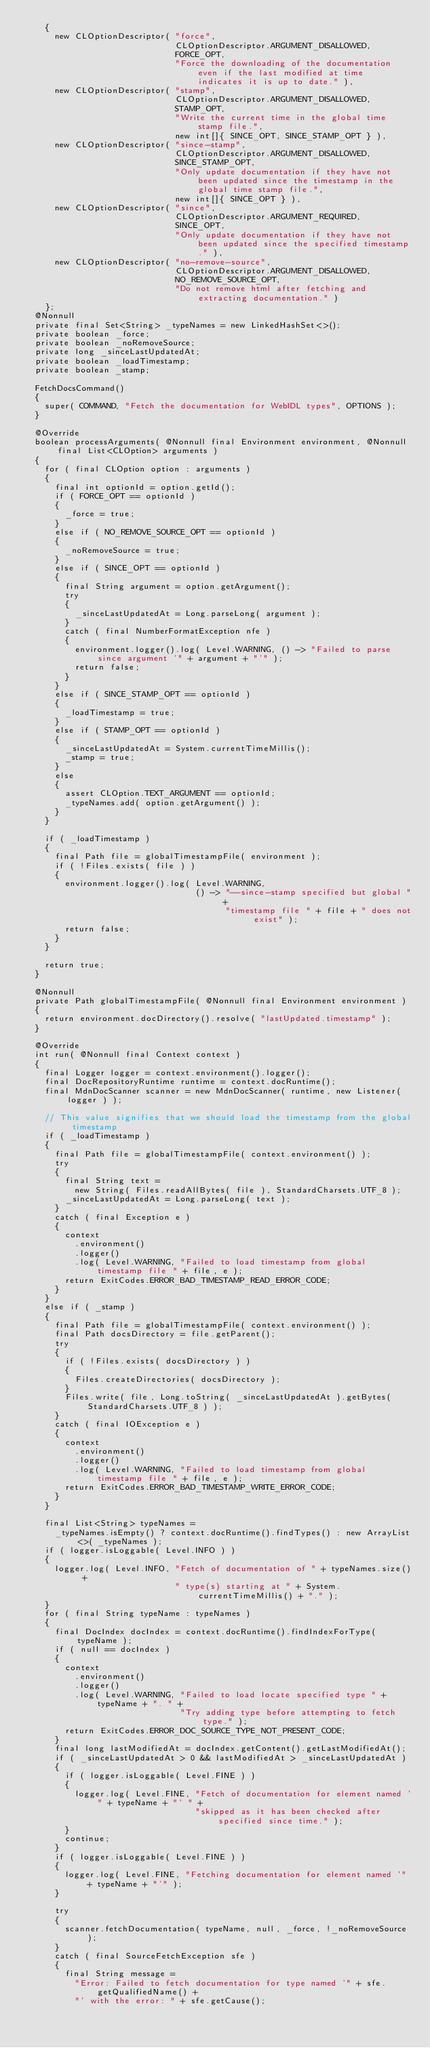<code> <loc_0><loc_0><loc_500><loc_500><_Java_>    {
      new CLOptionDescriptor( "force",
                              CLOptionDescriptor.ARGUMENT_DISALLOWED,
                              FORCE_OPT,
                              "Force the downloading of the documentation even if the last modified at time indicates it is up to date." ),
      new CLOptionDescriptor( "stamp",
                              CLOptionDescriptor.ARGUMENT_DISALLOWED,
                              STAMP_OPT,
                              "Write the current time in the global time stamp file.",
                              new int[]{ SINCE_OPT, SINCE_STAMP_OPT } ),
      new CLOptionDescriptor( "since-stamp",
                              CLOptionDescriptor.ARGUMENT_DISALLOWED,
                              SINCE_STAMP_OPT,
                              "Only update documentation if they have not been updated since the timestamp in the global time stamp file.",
                              new int[]{ SINCE_OPT } ),
      new CLOptionDescriptor( "since",
                              CLOptionDescriptor.ARGUMENT_REQUIRED,
                              SINCE_OPT,
                              "Only update documentation if they have not been updated since the specified timestamp." ),
      new CLOptionDescriptor( "no-remove-source",
                              CLOptionDescriptor.ARGUMENT_DISALLOWED,
                              NO_REMOVE_SOURCE_OPT,
                              "Do not remove html after fetching and extracting documentation." )
    };
  @Nonnull
  private final Set<String> _typeNames = new LinkedHashSet<>();
  private boolean _force;
  private boolean _noRemoveSource;
  private long _sinceLastUpdatedAt;
  private boolean _loadTimestamp;
  private boolean _stamp;

  FetchDocsCommand()
  {
    super( COMMAND, "Fetch the documentation for WebIDL types", OPTIONS );
  }

  @Override
  boolean processArguments( @Nonnull final Environment environment, @Nonnull final List<CLOption> arguments )
  {
    for ( final CLOption option : arguments )
    {
      final int optionId = option.getId();
      if ( FORCE_OPT == optionId )
      {
        _force = true;
      }
      else if ( NO_REMOVE_SOURCE_OPT == optionId )
      {
        _noRemoveSource = true;
      }
      else if ( SINCE_OPT == optionId )
      {
        final String argument = option.getArgument();
        try
        {
          _sinceLastUpdatedAt = Long.parseLong( argument );
        }
        catch ( final NumberFormatException nfe )
        {
          environment.logger().log( Level.WARNING, () -> "Failed to parse since argument '" + argument + "'" );
          return false;
        }
      }
      else if ( SINCE_STAMP_OPT == optionId )
      {
        _loadTimestamp = true;
      }
      else if ( STAMP_OPT == optionId )
      {
        _sinceLastUpdatedAt = System.currentTimeMillis();
        _stamp = true;
      }
      else
      {
        assert CLOption.TEXT_ARGUMENT == optionId;
        _typeNames.add( option.getArgument() );
      }
    }

    if ( _loadTimestamp )
    {
      final Path file = globalTimestampFile( environment );
      if ( !Files.exists( file ) )
      {
        environment.logger().log( Level.WARNING,
                                  () -> "--since-stamp specified but global " +
                                        "timestamp file " + file + " does not exist" );
        return false;
      }
    }

    return true;
  }

  @Nonnull
  private Path globalTimestampFile( @Nonnull final Environment environment )
  {
    return environment.docDirectory().resolve( "lastUpdated.timestamp" );
  }

  @Override
  int run( @Nonnull final Context context )
  {
    final Logger logger = context.environment().logger();
    final DocRepositoryRuntime runtime = context.docRuntime();
    final MdnDocScanner scanner = new MdnDocScanner( runtime, new Listener( logger ) );

    // This value signifies that we should load the timestamp from the global timestamp
    if ( _loadTimestamp )
    {
      final Path file = globalTimestampFile( context.environment() );
      try
      {
        final String text =
          new String( Files.readAllBytes( file ), StandardCharsets.UTF_8 );
        _sinceLastUpdatedAt = Long.parseLong( text );
      }
      catch ( final Exception e )
      {
        context
          .environment()
          .logger()
          .log( Level.WARNING, "Failed to load timestamp from global timestamp file " + file, e );
        return ExitCodes.ERROR_BAD_TIMESTAMP_READ_ERROR_CODE;
      }
    }
    else if ( _stamp )
    {
      final Path file = globalTimestampFile( context.environment() );
      final Path docsDirectory = file.getParent();
      try
      {
        if ( !Files.exists( docsDirectory ) )
        {
          Files.createDirectories( docsDirectory );
        }
        Files.write( file, Long.toString( _sinceLastUpdatedAt ).getBytes( StandardCharsets.UTF_8 ) );
      }
      catch ( final IOException e )
      {
        context
          .environment()
          .logger()
          .log( Level.WARNING, "Failed to load timestamp from global timestamp file " + file, e );
        return ExitCodes.ERROR_BAD_TIMESTAMP_WRITE_ERROR_CODE;
      }
    }

    final List<String> typeNames =
      _typeNames.isEmpty() ? context.docRuntime().findTypes() : new ArrayList<>( _typeNames );
    if ( logger.isLoggable( Level.INFO ) )
    {
      logger.log( Level.INFO, "Fetch of documentation of " + typeNames.size() +
                              " type(s) starting at " + System.currentTimeMillis() + "." );
    }
    for ( final String typeName : typeNames )
    {
      final DocIndex docIndex = context.docRuntime().findIndexForType( typeName );
      if ( null == docIndex )
      {
        context
          .environment()
          .logger()
          .log( Level.WARNING, "Failed to load locate specified type " + typeName + ". " +
                               "Try adding type before attempting to fetch type." );
        return ExitCodes.ERROR_DOC_SOURCE_TYPE_NOT_PRESENT_CODE;
      }
      final long lastModifiedAt = docIndex.getContent().getLastModifiedAt();
      if ( _sinceLastUpdatedAt > 0 && lastModifiedAt > _sinceLastUpdatedAt )
      {
        if ( logger.isLoggable( Level.FINE ) )
        {
          logger.log( Level.FINE, "Fetch of documentation for element named '" + typeName + "' " +
                                  "skipped as it has been checked after specified since time." );
        }
        continue;
      }
      if ( logger.isLoggable( Level.FINE ) )
      {
        logger.log( Level.FINE, "Fetching documentation for element named '" + typeName + "'" );
      }

      try
      {
        scanner.fetchDocumentation( typeName, null, _force, !_noRemoveSource );
      }
      catch ( final SourceFetchException sfe )
      {
        final String message =
          "Error: Failed to fetch documentation for type named '" + sfe.getQualifiedName() +
          "' with the error: " + sfe.getCause();</code> 